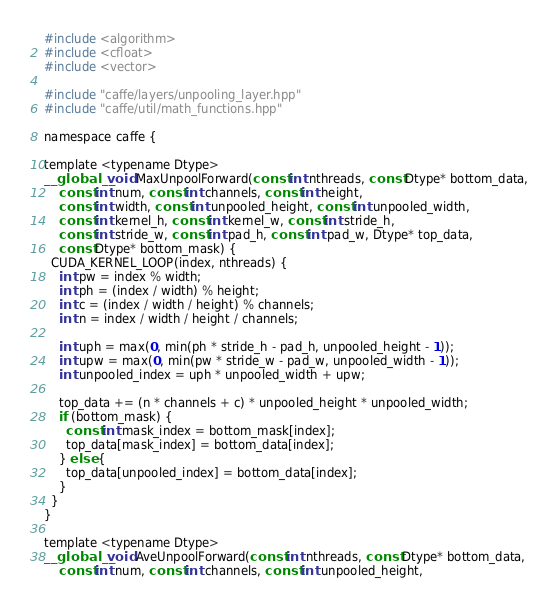Convert code to text. <code><loc_0><loc_0><loc_500><loc_500><_Cuda_>#include <algorithm>
#include <cfloat>
#include <vector>

#include "caffe/layers/unpooling_layer.hpp"
#include "caffe/util/math_functions.hpp"

namespace caffe {

template <typename Dtype>
__global__ void MaxUnpoolForward(const int nthreads, const Dtype* bottom_data,
    const int num, const int channels, const int height,
    const int width, const int unpooled_height, const int unpooled_width,
    const int kernel_h, const int kernel_w, const int stride_h,
    const int stride_w, const int pad_h, const int pad_w, Dtype* top_data,
    const Dtype* bottom_mask) {
  CUDA_KERNEL_LOOP(index, nthreads) {
    int pw = index % width;
    int ph = (index / width) % height;
    int c = (index / width / height) % channels;
    int n = index / width / height / channels;
  
    int uph = max(0, min(ph * stride_h - pad_h, unpooled_height - 1));
    int upw = max(0, min(pw * stride_w - pad_w, unpooled_width - 1));
    int unpooled_index = uph * unpooled_width + upw;

    top_data += (n * channels + c) * unpooled_height * unpooled_width;
    if (bottom_mask) {
      const int mask_index = bottom_mask[index];
      top_data[mask_index] = bottom_data[index]; 
    } else {
      top_data[unpooled_index] = bottom_data[index];
    } 
  }
}

template <typename Dtype>
__global__ void AveUnpoolForward(const int nthreads, const Dtype* bottom_data,
    const int num, const int channels, const int unpooled_height,</code> 